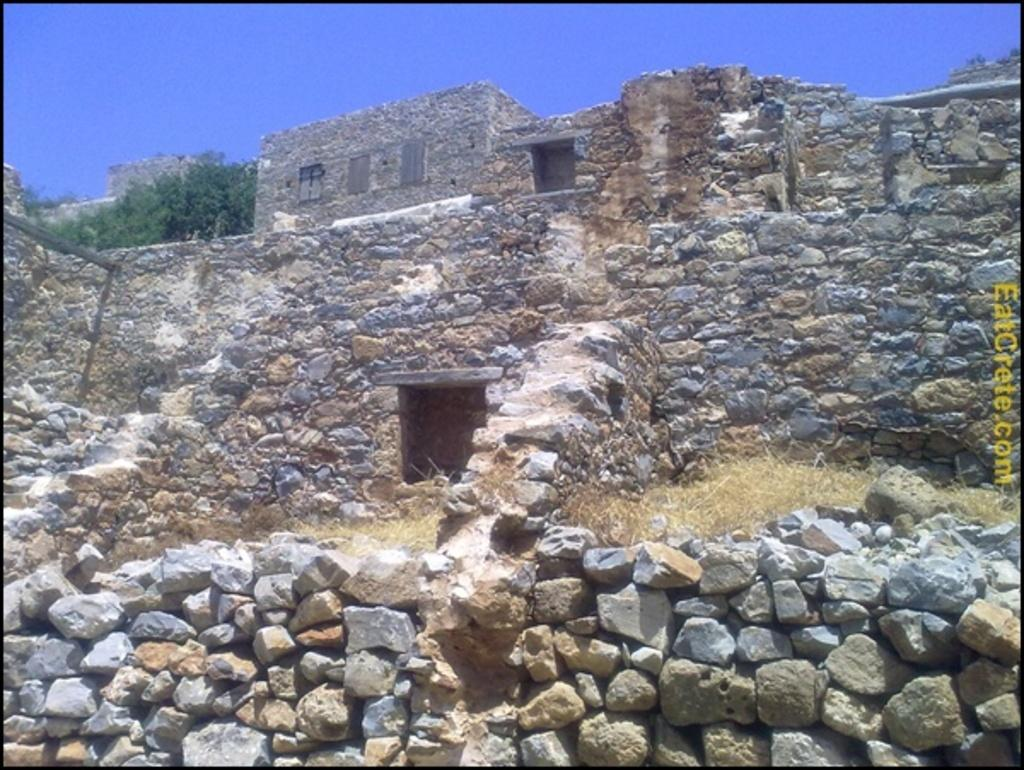What type of natural elements can be seen in the image? There are rocks, grass, and trees in the image. What man-made structure is present in the image? There is a fort in the image. What is visible in the background of the image? The sky is visible in the image. What additional feature can be found on the right side of the image? There is a watermark on the right side of the image. What type of bun is being used to hold the fort in the image? There is no bun present in the image; it features a fort made of man-made materials. How does the slip affect the stability of the rocks in the image? There is no slip mentioned in the image, and the stability of the rocks is not affected by any such object. 